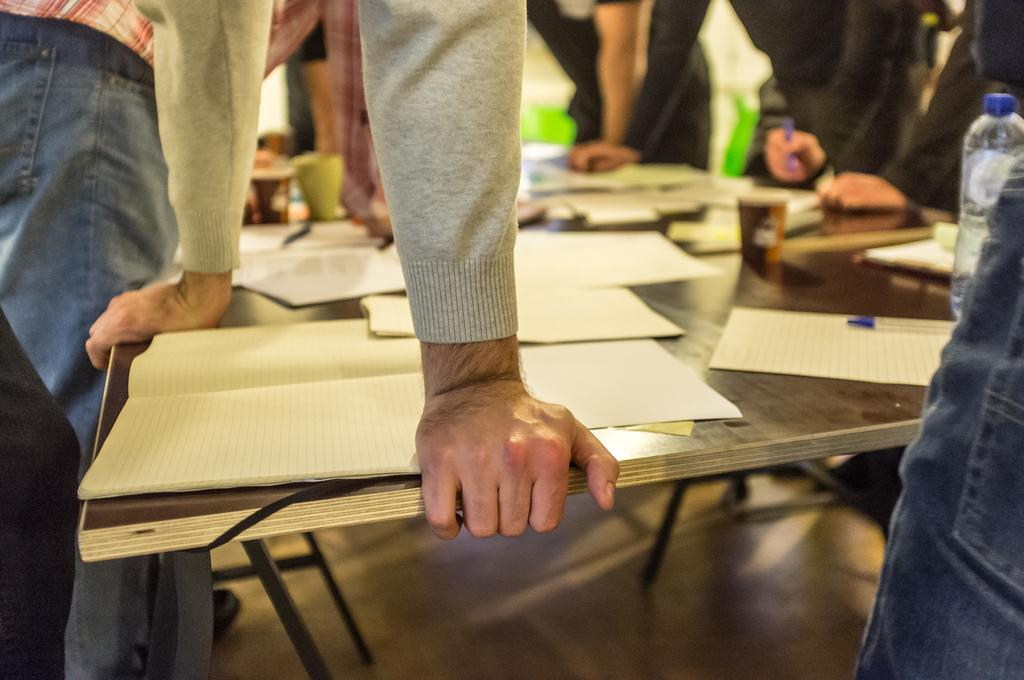What type of furniture is present in the image? There is a table in the image. What can be seen on the table? Multiple persons' hands are visible on the table, as well as a paper bottle and a pen. What type of apparel is being used to write on the paper bottle in the image? There is no apparel being used to write on the paper bottle in the image; it is the pen that is visible on the table. 